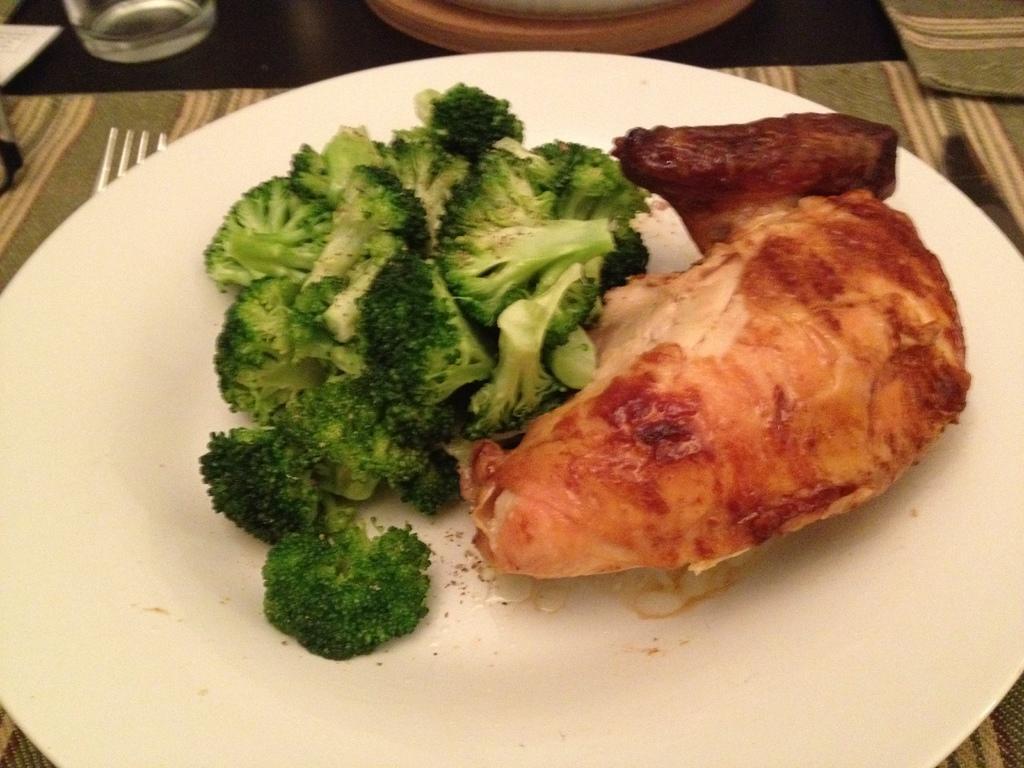Please provide a concise description of this image. In this image I can see a plate , on the plate I can see a food item and plate is kept on the table , on the table I can see a fork, glass 